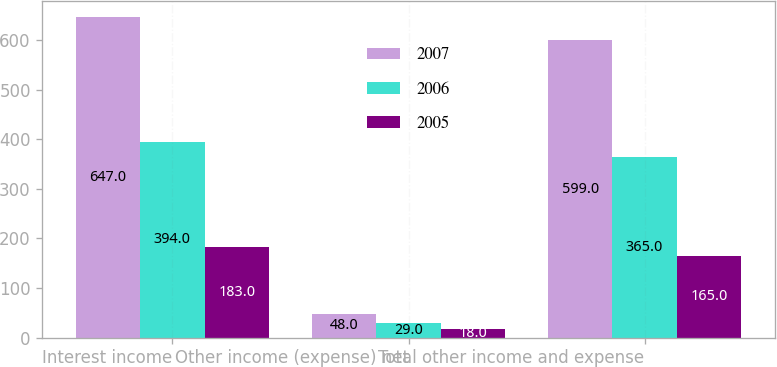Convert chart. <chart><loc_0><loc_0><loc_500><loc_500><stacked_bar_chart><ecel><fcel>Interest income<fcel>Other income (expense) net<fcel>Total other income and expense<nl><fcel>2007<fcel>647<fcel>48<fcel>599<nl><fcel>2006<fcel>394<fcel>29<fcel>365<nl><fcel>2005<fcel>183<fcel>18<fcel>165<nl></chart> 